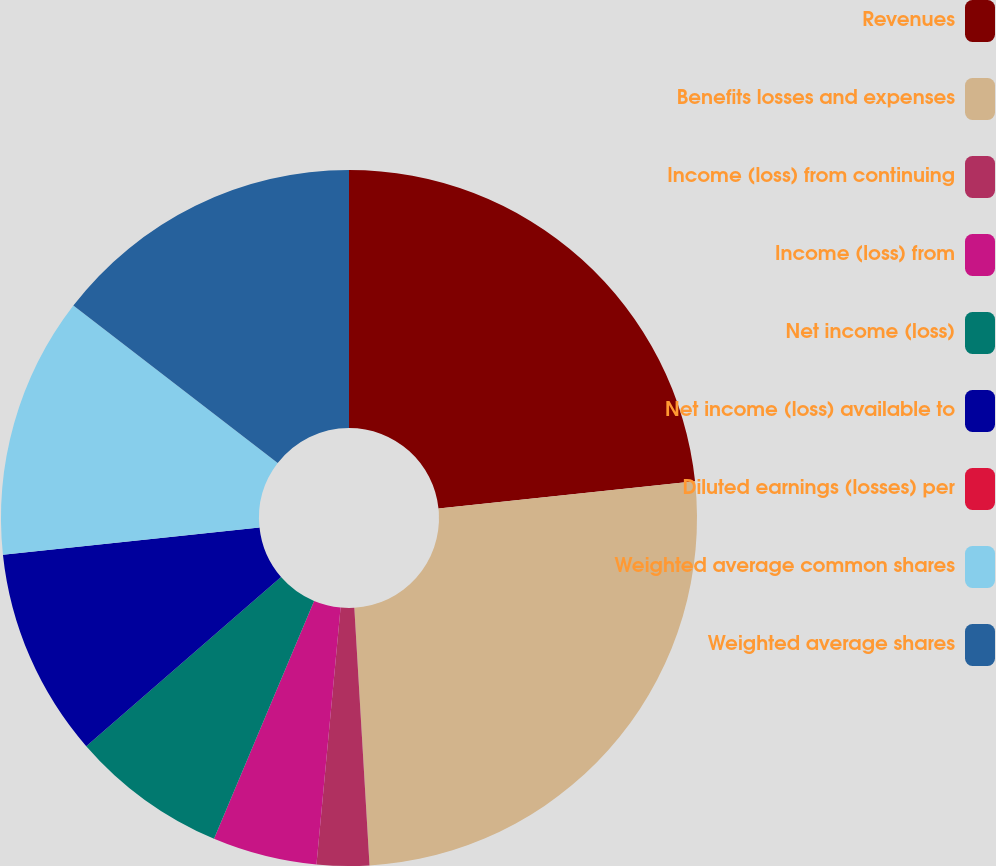Convert chart. <chart><loc_0><loc_0><loc_500><loc_500><pie_chart><fcel>Revenues<fcel>Benefits losses and expenses<fcel>Income (loss) from continuing<fcel>Income (loss) from<fcel>Net income (loss)<fcel>Net income (loss) available to<fcel>Diluted earnings (losses) per<fcel>Weighted average common shares<fcel>Weighted average shares<nl><fcel>23.32%<fcel>25.74%<fcel>2.43%<fcel>4.85%<fcel>7.28%<fcel>9.7%<fcel>0.0%<fcel>12.13%<fcel>14.55%<nl></chart> 